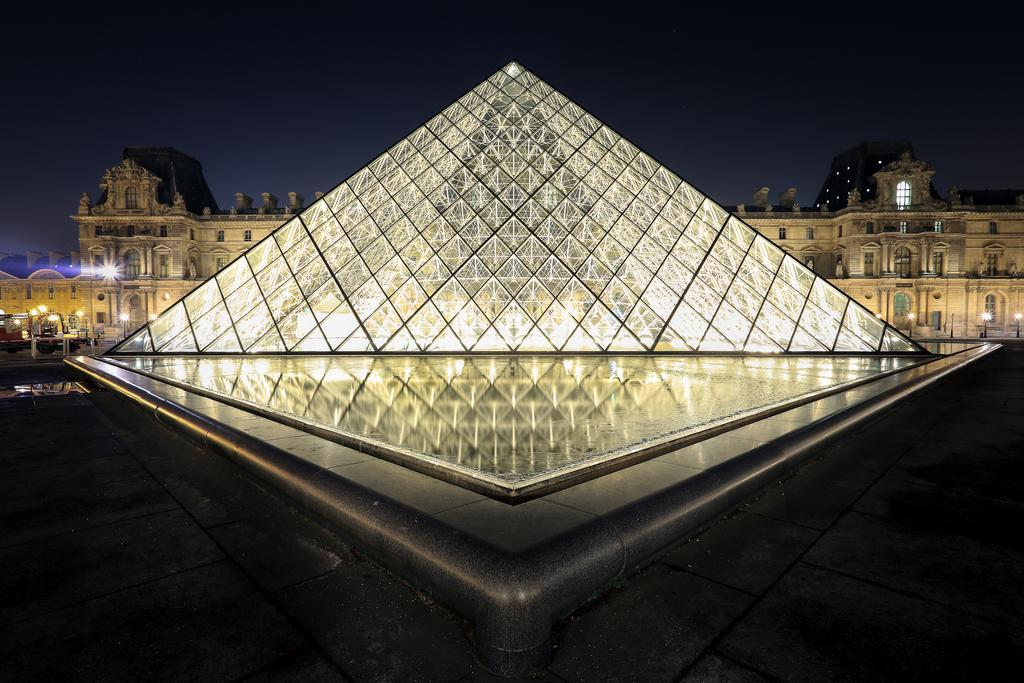What is the main structure in the image? There is a pyramid in the image. What else can be seen in the background of the image? There is a building in the background of the image. What is visible at the top of the image? The sky is visible at the top of the image. What is present in the front of the image? There is water visible in the front of the image. What type of plantation can be seen near the pyramid in the image? There is no plantation present in the image; it features a pyramid, a building, the sky, and water. 